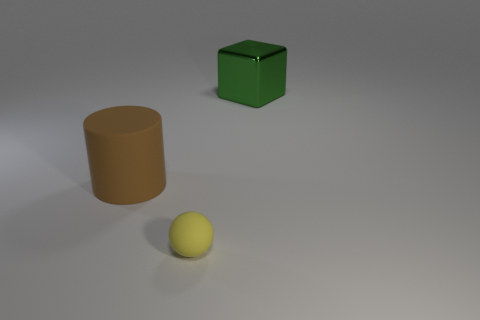Are there any other things that are the same material as the large green block?
Offer a very short reply. No. Are there any other things that are the same size as the rubber ball?
Give a very brief answer. No. The big metal object has what shape?
Ensure brevity in your answer.  Cube. What is the size of the thing in front of the big object to the left of the big thing that is to the right of the big brown rubber object?
Ensure brevity in your answer.  Small. How many other things are there of the same shape as the tiny rubber object?
Ensure brevity in your answer.  0. Do the object that is on the left side of the yellow object and the large thing behind the big matte thing have the same shape?
Offer a very short reply. No. How many balls are either small yellow things or large brown matte things?
Offer a terse response. 1. There is a big object that is in front of the object behind the big thing that is left of the large metal cube; what is its material?
Make the answer very short. Rubber. How many other objects are the same size as the yellow rubber thing?
Your answer should be compact. 0. Are there more large green metallic cubes in front of the large brown matte cylinder than large rubber objects?
Your response must be concise. No. 